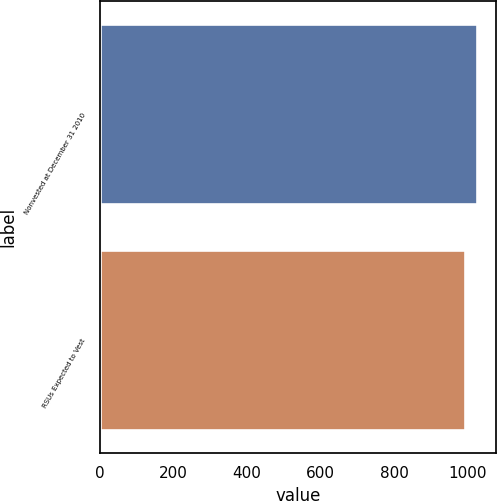Convert chart to OTSL. <chart><loc_0><loc_0><loc_500><loc_500><bar_chart><fcel>Nonvested at December 31 2010<fcel>RSUs Expected to Vest<nl><fcel>1024<fcel>991<nl></chart> 